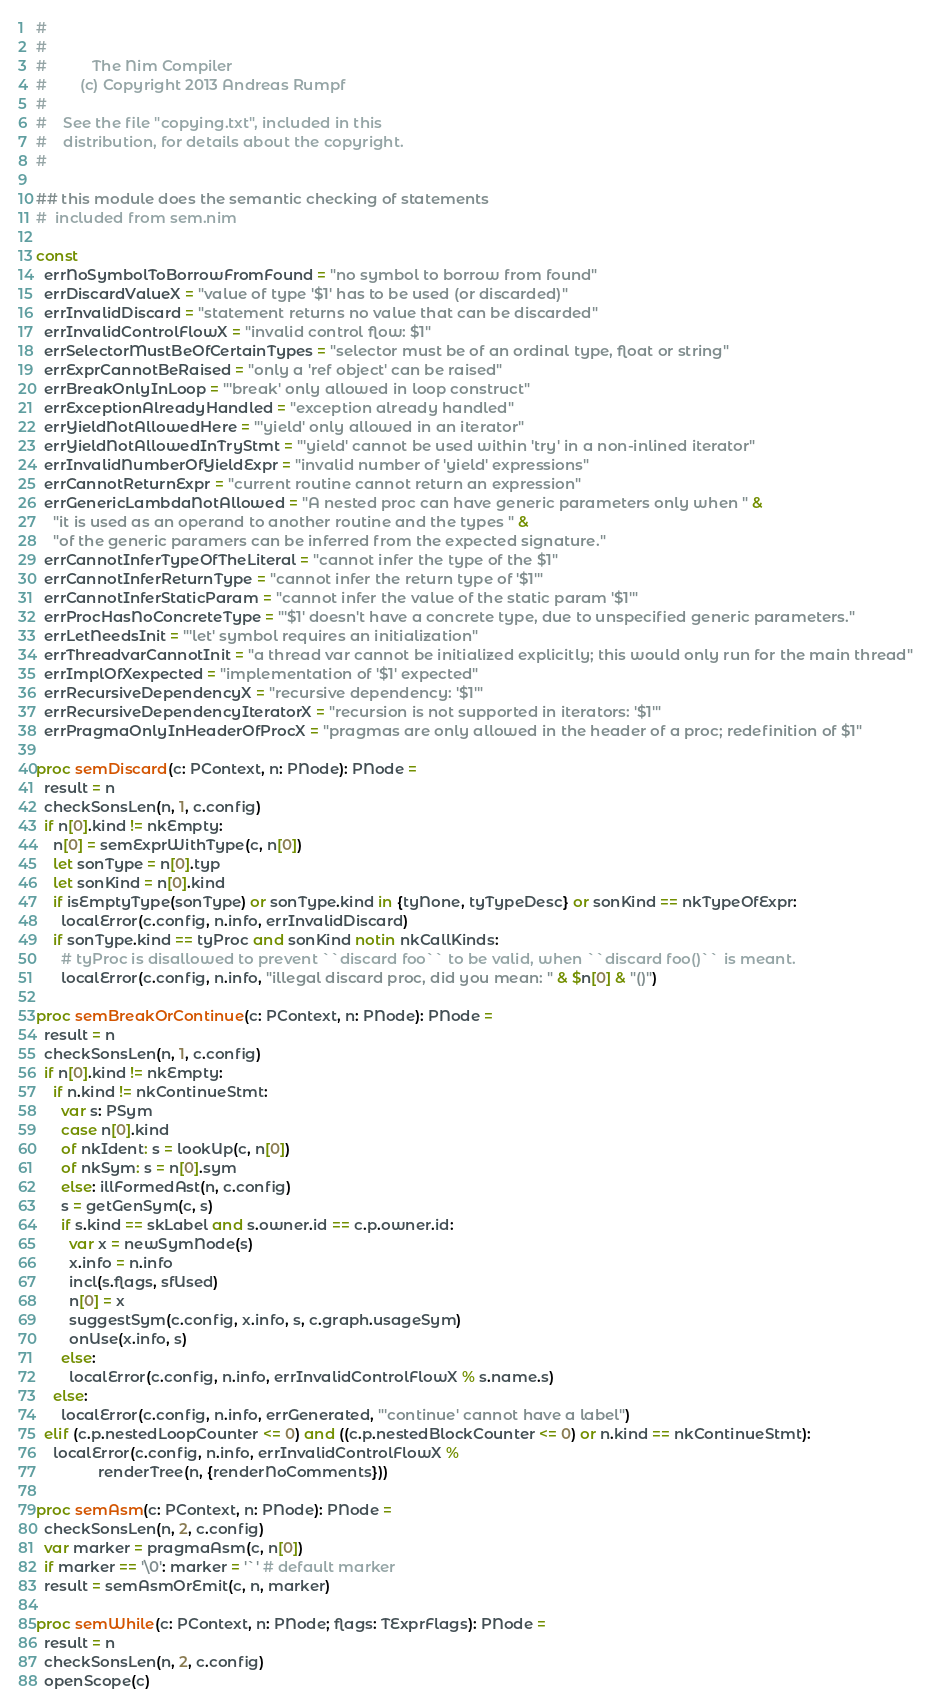Convert code to text. <code><loc_0><loc_0><loc_500><loc_500><_Nim_>#
#
#           The Nim Compiler
#        (c) Copyright 2013 Andreas Rumpf
#
#    See the file "copying.txt", included in this
#    distribution, for details about the copyright.
#

## this module does the semantic checking of statements
#  included from sem.nim

const
  errNoSymbolToBorrowFromFound = "no symbol to borrow from found"
  errDiscardValueX = "value of type '$1' has to be used (or discarded)"
  errInvalidDiscard = "statement returns no value that can be discarded"
  errInvalidControlFlowX = "invalid control flow: $1"
  errSelectorMustBeOfCertainTypes = "selector must be of an ordinal type, float or string"
  errExprCannotBeRaised = "only a 'ref object' can be raised"
  errBreakOnlyInLoop = "'break' only allowed in loop construct"
  errExceptionAlreadyHandled = "exception already handled"
  errYieldNotAllowedHere = "'yield' only allowed in an iterator"
  errYieldNotAllowedInTryStmt = "'yield' cannot be used within 'try' in a non-inlined iterator"
  errInvalidNumberOfYieldExpr = "invalid number of 'yield' expressions"
  errCannotReturnExpr = "current routine cannot return an expression"
  errGenericLambdaNotAllowed = "A nested proc can have generic parameters only when " &
    "it is used as an operand to another routine and the types " &
    "of the generic paramers can be inferred from the expected signature."
  errCannotInferTypeOfTheLiteral = "cannot infer the type of the $1"
  errCannotInferReturnType = "cannot infer the return type of '$1'"
  errCannotInferStaticParam = "cannot infer the value of the static param '$1'"
  errProcHasNoConcreteType = "'$1' doesn't have a concrete type, due to unspecified generic parameters."
  errLetNeedsInit = "'let' symbol requires an initialization"
  errThreadvarCannotInit = "a thread var cannot be initialized explicitly; this would only run for the main thread"
  errImplOfXexpected = "implementation of '$1' expected"
  errRecursiveDependencyX = "recursive dependency: '$1'"
  errRecursiveDependencyIteratorX = "recursion is not supported in iterators: '$1'"
  errPragmaOnlyInHeaderOfProcX = "pragmas are only allowed in the header of a proc; redefinition of $1"

proc semDiscard(c: PContext, n: PNode): PNode =
  result = n
  checkSonsLen(n, 1, c.config)
  if n[0].kind != nkEmpty:
    n[0] = semExprWithType(c, n[0])
    let sonType = n[0].typ
    let sonKind = n[0].kind
    if isEmptyType(sonType) or sonType.kind in {tyNone, tyTypeDesc} or sonKind == nkTypeOfExpr:
      localError(c.config, n.info, errInvalidDiscard)
    if sonType.kind == tyProc and sonKind notin nkCallKinds:
      # tyProc is disallowed to prevent ``discard foo`` to be valid, when ``discard foo()`` is meant.
      localError(c.config, n.info, "illegal discard proc, did you mean: " & $n[0] & "()")

proc semBreakOrContinue(c: PContext, n: PNode): PNode =
  result = n
  checkSonsLen(n, 1, c.config)
  if n[0].kind != nkEmpty:
    if n.kind != nkContinueStmt:
      var s: PSym
      case n[0].kind
      of nkIdent: s = lookUp(c, n[0])
      of nkSym: s = n[0].sym
      else: illFormedAst(n, c.config)
      s = getGenSym(c, s)
      if s.kind == skLabel and s.owner.id == c.p.owner.id:
        var x = newSymNode(s)
        x.info = n.info
        incl(s.flags, sfUsed)
        n[0] = x
        suggestSym(c.config, x.info, s, c.graph.usageSym)
        onUse(x.info, s)
      else:
        localError(c.config, n.info, errInvalidControlFlowX % s.name.s)
    else:
      localError(c.config, n.info, errGenerated, "'continue' cannot have a label")
  elif (c.p.nestedLoopCounter <= 0) and ((c.p.nestedBlockCounter <= 0) or n.kind == nkContinueStmt):
    localError(c.config, n.info, errInvalidControlFlowX %
               renderTree(n, {renderNoComments}))

proc semAsm(c: PContext, n: PNode): PNode =
  checkSonsLen(n, 2, c.config)
  var marker = pragmaAsm(c, n[0])
  if marker == '\0': marker = '`' # default marker
  result = semAsmOrEmit(c, n, marker)

proc semWhile(c: PContext, n: PNode; flags: TExprFlags): PNode =
  result = n
  checkSonsLen(n, 2, c.config)
  openScope(c)</code> 